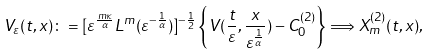<formula> <loc_0><loc_0><loc_500><loc_500>V _ { \varepsilon } ( t , x ) \colon = [ \varepsilon ^ { \frac { m \kappa } { \alpha } } L ^ { m } ( \varepsilon ^ { - \frac { 1 } { \alpha } } ) ] ^ { - \frac { 1 } { 2 } } \left \{ V ( \frac { t } { \varepsilon } , \frac { x } { \varepsilon ^ { \frac { 1 } { \alpha } } } ) - C _ { 0 } ^ { ( 2 ) } \right \} \Longrightarrow X ^ { ( 2 ) } _ { m } ( t , x ) ,</formula> 